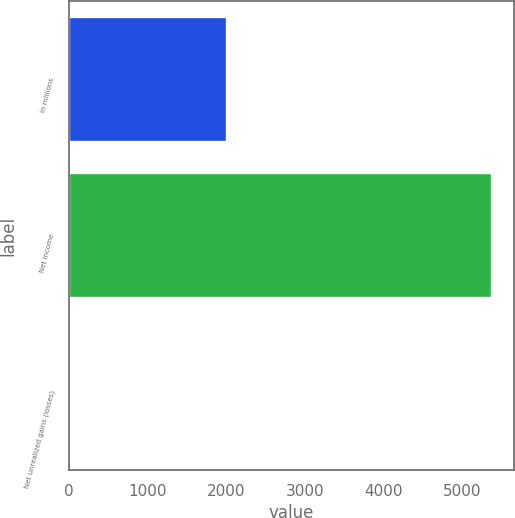<chart> <loc_0><loc_0><loc_500><loc_500><bar_chart><fcel>In millions<fcel>Net income<fcel>Net unrealized gains (losses)<nl><fcel>2017<fcel>5388<fcel>16<nl></chart> 